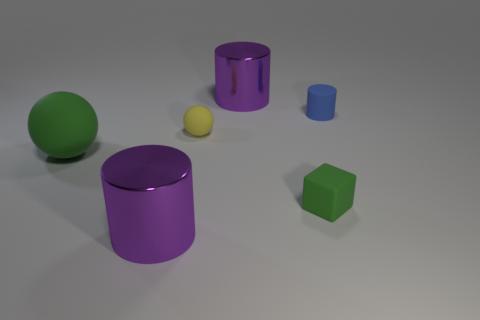Subtract all purple cylinders. How many cylinders are left? 1 Add 4 yellow objects. How many objects exist? 10 Subtract all blocks. How many objects are left? 5 Add 3 tiny blue cylinders. How many tiny blue cylinders are left? 4 Add 6 big green balls. How many big green balls exist? 7 Subtract 0 purple cubes. How many objects are left? 6 Subtract all gray rubber things. Subtract all tiny blue things. How many objects are left? 5 